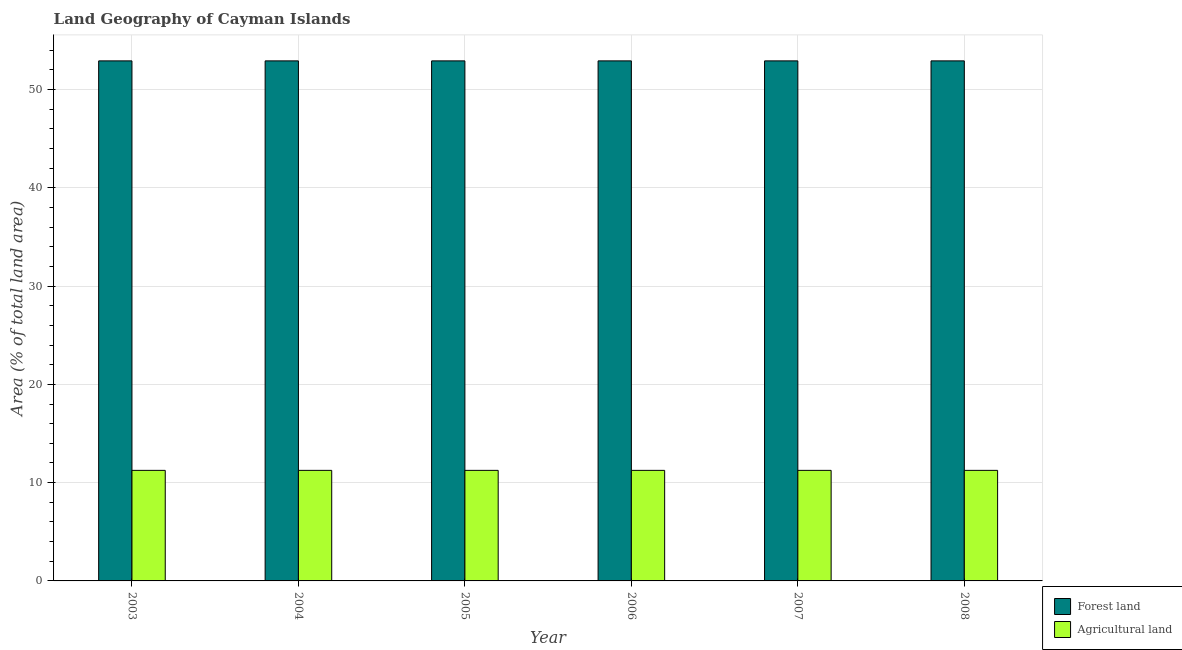How many different coloured bars are there?
Your response must be concise. 2. How many groups of bars are there?
Ensure brevity in your answer.  6. How many bars are there on the 2nd tick from the right?
Your answer should be very brief. 2. What is the label of the 5th group of bars from the left?
Provide a succinct answer. 2007. In how many cases, is the number of bars for a given year not equal to the number of legend labels?
Your answer should be compact. 0. What is the percentage of land area under agriculture in 2004?
Your answer should be compact. 11.25. Across all years, what is the maximum percentage of land area under agriculture?
Your answer should be compact. 11.25. Across all years, what is the minimum percentage of land area under agriculture?
Ensure brevity in your answer.  11.25. In which year was the percentage of land area under agriculture minimum?
Your answer should be very brief. 2003. What is the total percentage of land area under forests in the graph?
Give a very brief answer. 317.5. What is the average percentage of land area under agriculture per year?
Your answer should be very brief. 11.25. In how many years, is the percentage of land area under forests greater than 20 %?
Ensure brevity in your answer.  6. Is the percentage of land area under forests in 2003 less than that in 2007?
Your response must be concise. No. What does the 1st bar from the left in 2005 represents?
Give a very brief answer. Forest land. What does the 2nd bar from the right in 2003 represents?
Your answer should be compact. Forest land. How many years are there in the graph?
Give a very brief answer. 6. Are the values on the major ticks of Y-axis written in scientific E-notation?
Offer a terse response. No. Does the graph contain any zero values?
Provide a succinct answer. No. Where does the legend appear in the graph?
Provide a short and direct response. Bottom right. What is the title of the graph?
Provide a short and direct response. Land Geography of Cayman Islands. Does "Travel services" appear as one of the legend labels in the graph?
Give a very brief answer. No. What is the label or title of the X-axis?
Provide a short and direct response. Year. What is the label or title of the Y-axis?
Keep it short and to the point. Area (% of total land area). What is the Area (% of total land area) of Forest land in 2003?
Provide a short and direct response. 52.92. What is the Area (% of total land area) of Agricultural land in 2003?
Make the answer very short. 11.25. What is the Area (% of total land area) of Forest land in 2004?
Make the answer very short. 52.92. What is the Area (% of total land area) in Agricultural land in 2004?
Provide a short and direct response. 11.25. What is the Area (% of total land area) in Forest land in 2005?
Make the answer very short. 52.92. What is the Area (% of total land area) of Agricultural land in 2005?
Offer a very short reply. 11.25. What is the Area (% of total land area) in Forest land in 2006?
Make the answer very short. 52.92. What is the Area (% of total land area) in Agricultural land in 2006?
Offer a terse response. 11.25. What is the Area (% of total land area) in Forest land in 2007?
Offer a terse response. 52.92. What is the Area (% of total land area) of Agricultural land in 2007?
Your response must be concise. 11.25. What is the Area (% of total land area) in Forest land in 2008?
Provide a succinct answer. 52.92. What is the Area (% of total land area) in Agricultural land in 2008?
Your answer should be very brief. 11.25. Across all years, what is the maximum Area (% of total land area) in Forest land?
Your answer should be compact. 52.92. Across all years, what is the maximum Area (% of total land area) of Agricultural land?
Keep it short and to the point. 11.25. Across all years, what is the minimum Area (% of total land area) in Forest land?
Ensure brevity in your answer.  52.92. Across all years, what is the minimum Area (% of total land area) in Agricultural land?
Your answer should be very brief. 11.25. What is the total Area (% of total land area) of Forest land in the graph?
Your answer should be very brief. 317.5. What is the total Area (% of total land area) in Agricultural land in the graph?
Keep it short and to the point. 67.5. What is the difference between the Area (% of total land area) of Agricultural land in 2003 and that in 2004?
Give a very brief answer. 0. What is the difference between the Area (% of total land area) in Agricultural land in 2003 and that in 2005?
Offer a very short reply. 0. What is the difference between the Area (% of total land area) in Agricultural land in 2003 and that in 2006?
Ensure brevity in your answer.  0. What is the difference between the Area (% of total land area) of Forest land in 2003 and that in 2007?
Your answer should be compact. 0. What is the difference between the Area (% of total land area) of Agricultural land in 2003 and that in 2007?
Your answer should be very brief. 0. What is the difference between the Area (% of total land area) of Forest land in 2004 and that in 2007?
Offer a terse response. 0. What is the difference between the Area (% of total land area) of Agricultural land in 2004 and that in 2007?
Keep it short and to the point. 0. What is the difference between the Area (% of total land area) of Forest land in 2004 and that in 2008?
Ensure brevity in your answer.  0. What is the difference between the Area (% of total land area) in Agricultural land in 2004 and that in 2008?
Provide a short and direct response. 0. What is the difference between the Area (% of total land area) in Agricultural land in 2005 and that in 2006?
Offer a terse response. 0. What is the difference between the Area (% of total land area) of Forest land in 2005 and that in 2007?
Provide a short and direct response. 0. What is the difference between the Area (% of total land area) of Forest land in 2005 and that in 2008?
Give a very brief answer. 0. What is the difference between the Area (% of total land area) in Agricultural land in 2005 and that in 2008?
Provide a short and direct response. 0. What is the difference between the Area (% of total land area) of Forest land in 2006 and that in 2007?
Offer a very short reply. 0. What is the difference between the Area (% of total land area) in Agricultural land in 2006 and that in 2008?
Your answer should be very brief. 0. What is the difference between the Area (% of total land area) of Agricultural land in 2007 and that in 2008?
Your answer should be very brief. 0. What is the difference between the Area (% of total land area) of Forest land in 2003 and the Area (% of total land area) of Agricultural land in 2004?
Provide a succinct answer. 41.67. What is the difference between the Area (% of total land area) of Forest land in 2003 and the Area (% of total land area) of Agricultural land in 2005?
Ensure brevity in your answer.  41.67. What is the difference between the Area (% of total land area) of Forest land in 2003 and the Area (% of total land area) of Agricultural land in 2006?
Your answer should be compact. 41.67. What is the difference between the Area (% of total land area) of Forest land in 2003 and the Area (% of total land area) of Agricultural land in 2007?
Ensure brevity in your answer.  41.67. What is the difference between the Area (% of total land area) of Forest land in 2003 and the Area (% of total land area) of Agricultural land in 2008?
Give a very brief answer. 41.67. What is the difference between the Area (% of total land area) of Forest land in 2004 and the Area (% of total land area) of Agricultural land in 2005?
Ensure brevity in your answer.  41.67. What is the difference between the Area (% of total land area) in Forest land in 2004 and the Area (% of total land area) in Agricultural land in 2006?
Your response must be concise. 41.67. What is the difference between the Area (% of total land area) in Forest land in 2004 and the Area (% of total land area) in Agricultural land in 2007?
Keep it short and to the point. 41.67. What is the difference between the Area (% of total land area) of Forest land in 2004 and the Area (% of total land area) of Agricultural land in 2008?
Your response must be concise. 41.67. What is the difference between the Area (% of total land area) of Forest land in 2005 and the Area (% of total land area) of Agricultural land in 2006?
Provide a succinct answer. 41.67. What is the difference between the Area (% of total land area) in Forest land in 2005 and the Area (% of total land area) in Agricultural land in 2007?
Keep it short and to the point. 41.67. What is the difference between the Area (% of total land area) in Forest land in 2005 and the Area (% of total land area) in Agricultural land in 2008?
Provide a succinct answer. 41.67. What is the difference between the Area (% of total land area) of Forest land in 2006 and the Area (% of total land area) of Agricultural land in 2007?
Your answer should be very brief. 41.67. What is the difference between the Area (% of total land area) in Forest land in 2006 and the Area (% of total land area) in Agricultural land in 2008?
Your answer should be very brief. 41.67. What is the difference between the Area (% of total land area) of Forest land in 2007 and the Area (% of total land area) of Agricultural land in 2008?
Provide a succinct answer. 41.67. What is the average Area (% of total land area) of Forest land per year?
Make the answer very short. 52.92. What is the average Area (% of total land area) of Agricultural land per year?
Offer a very short reply. 11.25. In the year 2003, what is the difference between the Area (% of total land area) in Forest land and Area (% of total land area) in Agricultural land?
Keep it short and to the point. 41.67. In the year 2004, what is the difference between the Area (% of total land area) of Forest land and Area (% of total land area) of Agricultural land?
Offer a terse response. 41.67. In the year 2005, what is the difference between the Area (% of total land area) in Forest land and Area (% of total land area) in Agricultural land?
Give a very brief answer. 41.67. In the year 2006, what is the difference between the Area (% of total land area) of Forest land and Area (% of total land area) of Agricultural land?
Offer a very short reply. 41.67. In the year 2007, what is the difference between the Area (% of total land area) in Forest land and Area (% of total land area) in Agricultural land?
Offer a very short reply. 41.67. In the year 2008, what is the difference between the Area (% of total land area) in Forest land and Area (% of total land area) in Agricultural land?
Your response must be concise. 41.67. What is the ratio of the Area (% of total land area) in Agricultural land in 2003 to that in 2004?
Ensure brevity in your answer.  1. What is the ratio of the Area (% of total land area) of Forest land in 2003 to that in 2005?
Offer a very short reply. 1. What is the ratio of the Area (% of total land area) of Forest land in 2003 to that in 2008?
Your response must be concise. 1. What is the ratio of the Area (% of total land area) of Agricultural land in 2003 to that in 2008?
Keep it short and to the point. 1. What is the ratio of the Area (% of total land area) of Forest land in 2004 to that in 2005?
Offer a terse response. 1. What is the ratio of the Area (% of total land area) of Agricultural land in 2004 to that in 2006?
Your answer should be very brief. 1. What is the ratio of the Area (% of total land area) of Forest land in 2004 to that in 2007?
Give a very brief answer. 1. What is the ratio of the Area (% of total land area) of Agricultural land in 2004 to that in 2007?
Your answer should be very brief. 1. What is the ratio of the Area (% of total land area) of Forest land in 2004 to that in 2008?
Offer a very short reply. 1. What is the ratio of the Area (% of total land area) of Agricultural land in 2004 to that in 2008?
Your answer should be compact. 1. What is the ratio of the Area (% of total land area) in Agricultural land in 2005 to that in 2006?
Keep it short and to the point. 1. What is the ratio of the Area (% of total land area) in Agricultural land in 2006 to that in 2007?
Offer a very short reply. 1. What is the ratio of the Area (% of total land area) in Forest land in 2007 to that in 2008?
Your answer should be very brief. 1. What is the difference between the highest and the second highest Area (% of total land area) in Forest land?
Make the answer very short. 0. What is the difference between the highest and the second highest Area (% of total land area) of Agricultural land?
Keep it short and to the point. 0. What is the difference between the highest and the lowest Area (% of total land area) of Forest land?
Make the answer very short. 0. 